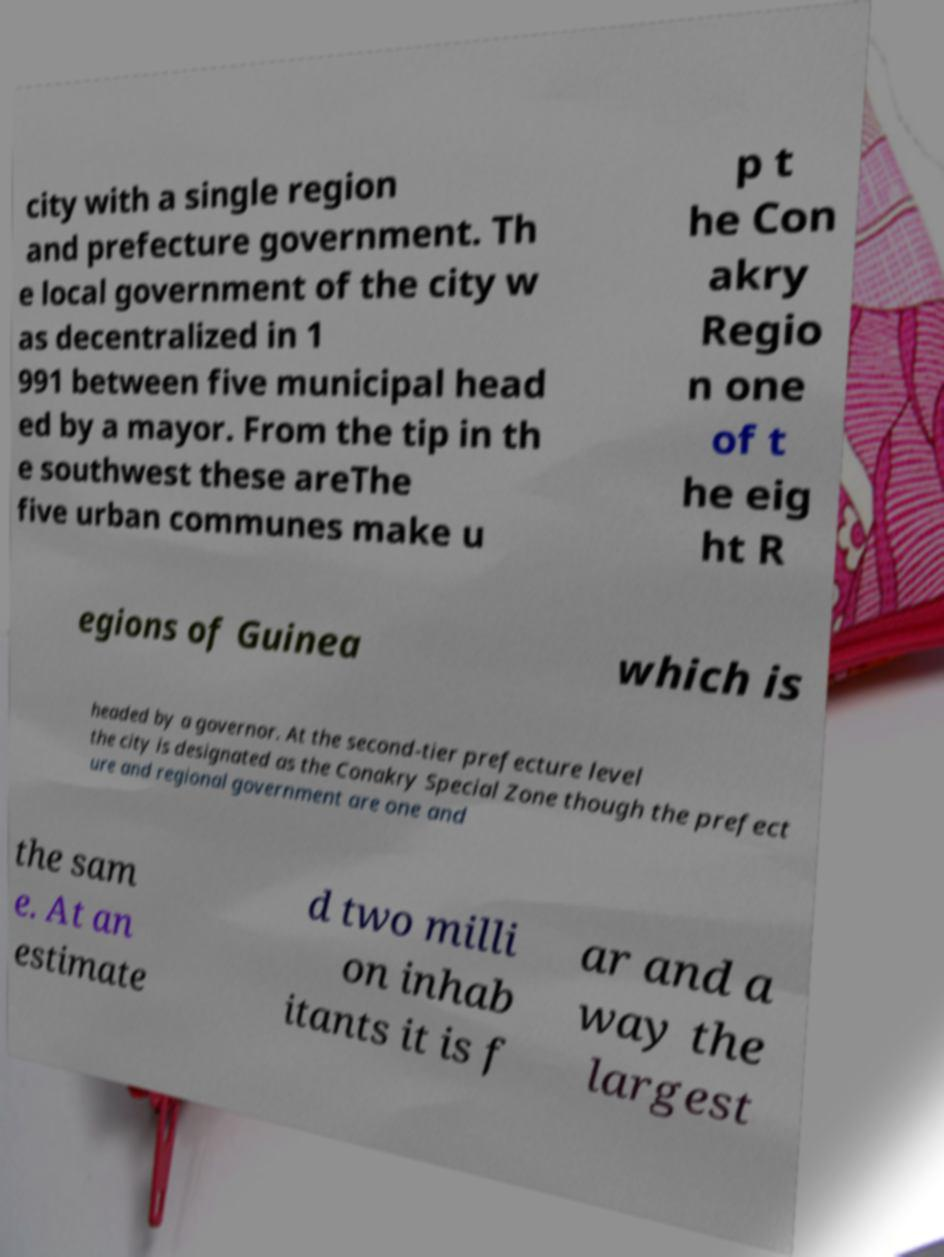For documentation purposes, I need the text within this image transcribed. Could you provide that? city with a single region and prefecture government. Th e local government of the city w as decentralized in 1 991 between five municipal head ed by a mayor. From the tip in th e southwest these areThe five urban communes make u p t he Con akry Regio n one of t he eig ht R egions of Guinea which is headed by a governor. At the second-tier prefecture level the city is designated as the Conakry Special Zone though the prefect ure and regional government are one and the sam e. At an estimate d two milli on inhab itants it is f ar and a way the largest 